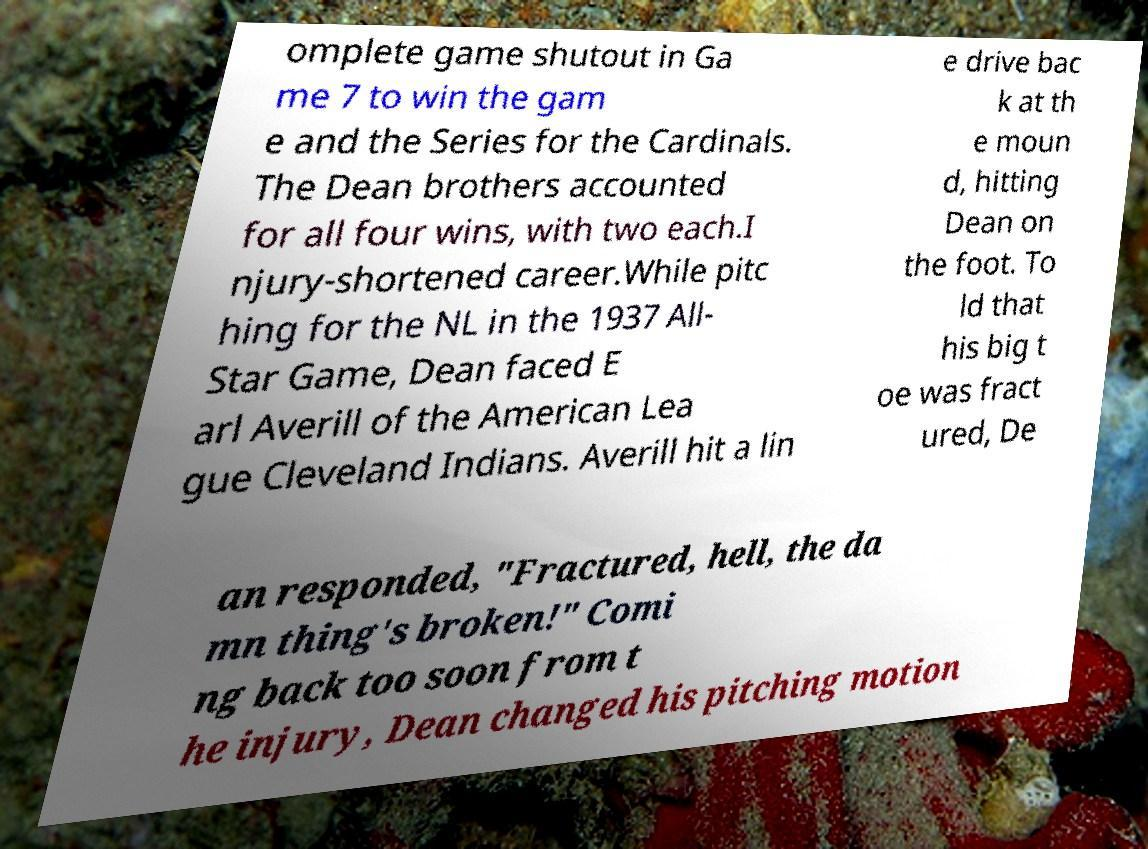Please identify and transcribe the text found in this image. omplete game shutout in Ga me 7 to win the gam e and the Series for the Cardinals. The Dean brothers accounted for all four wins, with two each.I njury-shortened career.While pitc hing for the NL in the 1937 All- Star Game, Dean faced E arl Averill of the American Lea gue Cleveland Indians. Averill hit a lin e drive bac k at th e moun d, hitting Dean on the foot. To ld that his big t oe was fract ured, De an responded, "Fractured, hell, the da mn thing's broken!" Comi ng back too soon from t he injury, Dean changed his pitching motion 